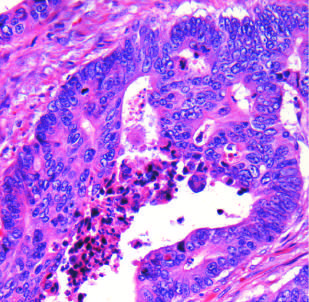re bile duct cells and canals of hering typical?
Answer the question using a single word or phrase. No 